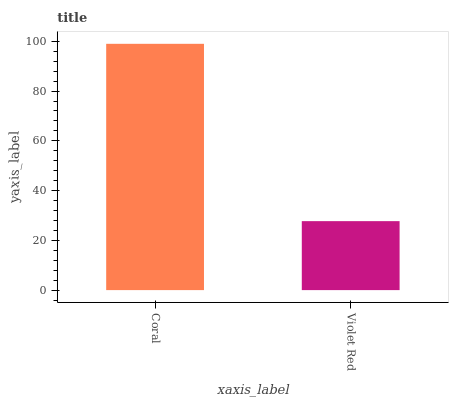Is Violet Red the minimum?
Answer yes or no. Yes. Is Coral the maximum?
Answer yes or no. Yes. Is Violet Red the maximum?
Answer yes or no. No. Is Coral greater than Violet Red?
Answer yes or no. Yes. Is Violet Red less than Coral?
Answer yes or no. Yes. Is Violet Red greater than Coral?
Answer yes or no. No. Is Coral less than Violet Red?
Answer yes or no. No. Is Coral the high median?
Answer yes or no. Yes. Is Violet Red the low median?
Answer yes or no. Yes. Is Violet Red the high median?
Answer yes or no. No. Is Coral the low median?
Answer yes or no. No. 